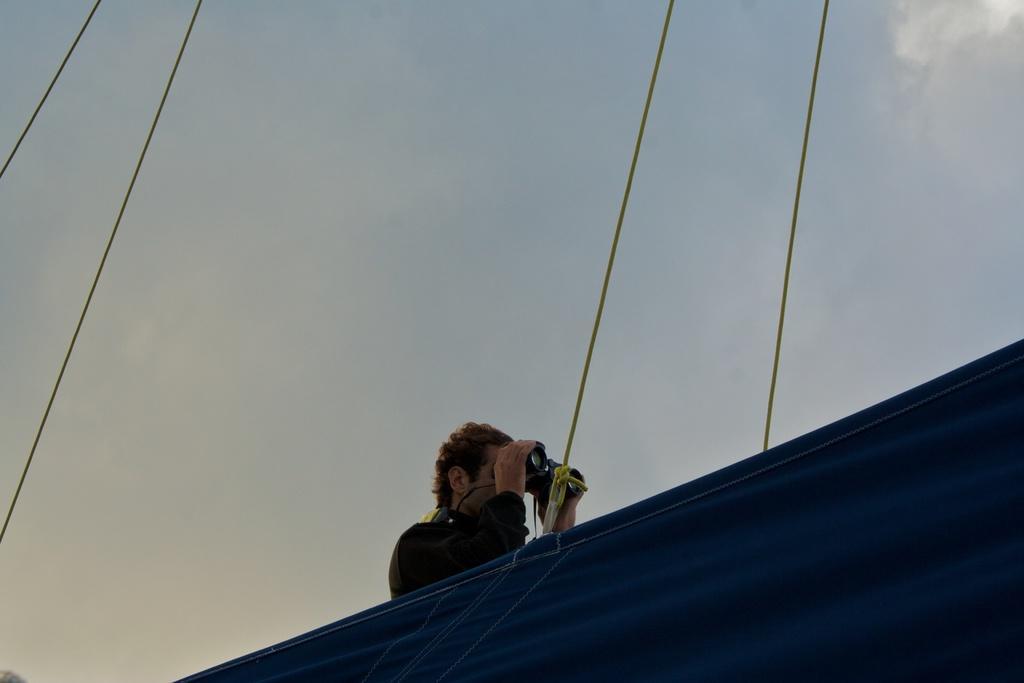In one or two sentences, can you explain what this image depicts? In this image we can see a person. In the background we can see sky and clouds. 